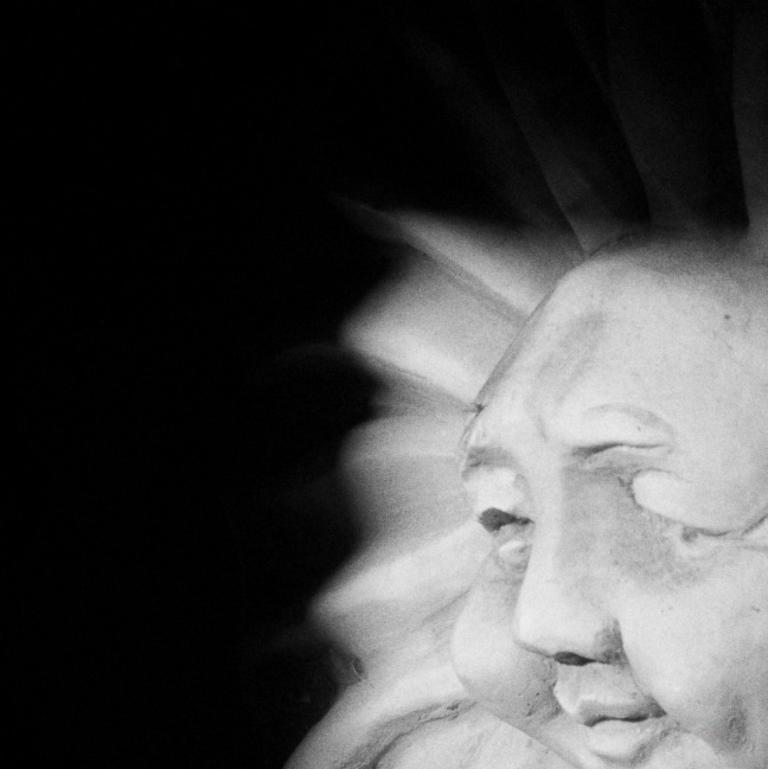What is the color scheme of the image? The image is black and white. What can be seen on the right side of the image? There is a statue in the shape of a human on the right side of the image. How many sheep are visible in the image? There are no sheep present in the image; it features a black and white statue in the shape of a human. What type of clouds can be seen in the image? There are no clouds visible in the image, as it is a black and white image of a statue. 